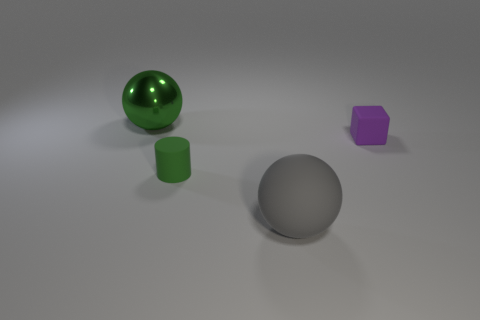Add 3 small metallic cylinders. How many objects exist? 7 Subtract all gray spheres. How many spheres are left? 1 Subtract all blocks. How many objects are left? 3 Add 3 gray rubber objects. How many gray rubber objects are left? 4 Add 3 big gray metallic balls. How many big gray metallic balls exist? 3 Subtract 0 cyan blocks. How many objects are left? 4 Subtract 1 blocks. How many blocks are left? 0 Subtract all red blocks. Subtract all blue balls. How many blocks are left? 1 Subtract all blue cylinders. How many cyan spheres are left? 0 Subtract all purple blocks. Subtract all small green things. How many objects are left? 2 